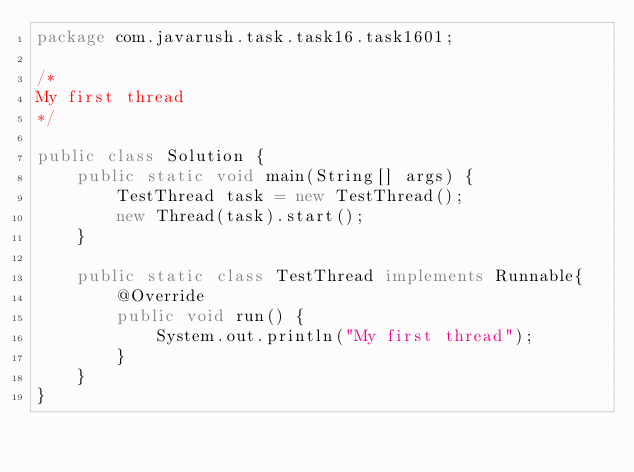Convert code to text. <code><loc_0><loc_0><loc_500><loc_500><_Java_>package com.javarush.task.task16.task1601;

/* 
My first thread
*/

public class Solution {
    public static void main(String[] args) {
        TestThread task = new TestThread();
        new Thread(task).start();
    }

    public static class TestThread implements Runnable{
        @Override
        public void run() {
            System.out.println("My first thread");
        }
    }
}
</code> 